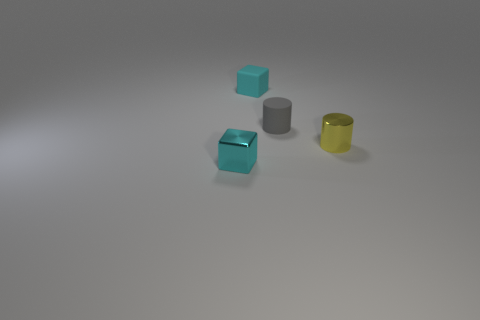The tiny matte object that is the same color as the metal cube is what shape?
Your response must be concise. Cube. Is the material of the small yellow thing the same as the gray cylinder?
Keep it short and to the point. No. There is a small gray rubber thing; how many small cyan cubes are behind it?
Provide a succinct answer. 1. The thing that is in front of the gray cylinder and behind the shiny block is made of what material?
Offer a terse response. Metal. How many balls are either rubber things or small yellow things?
Provide a short and direct response. 0. What material is the small yellow object that is the same shape as the gray object?
Make the answer very short. Metal. There is a cyan object that is made of the same material as the yellow object; what is its size?
Offer a very short reply. Small. Is the shape of the metal object in front of the small yellow thing the same as the cyan thing right of the small cyan shiny object?
Keep it short and to the point. Yes. There is a tiny block that is the same material as the gray object; what is its color?
Provide a succinct answer. Cyan. There is a tiny thing that is behind the yellow shiny object and left of the rubber cylinder; what is its shape?
Give a very brief answer. Cube. 